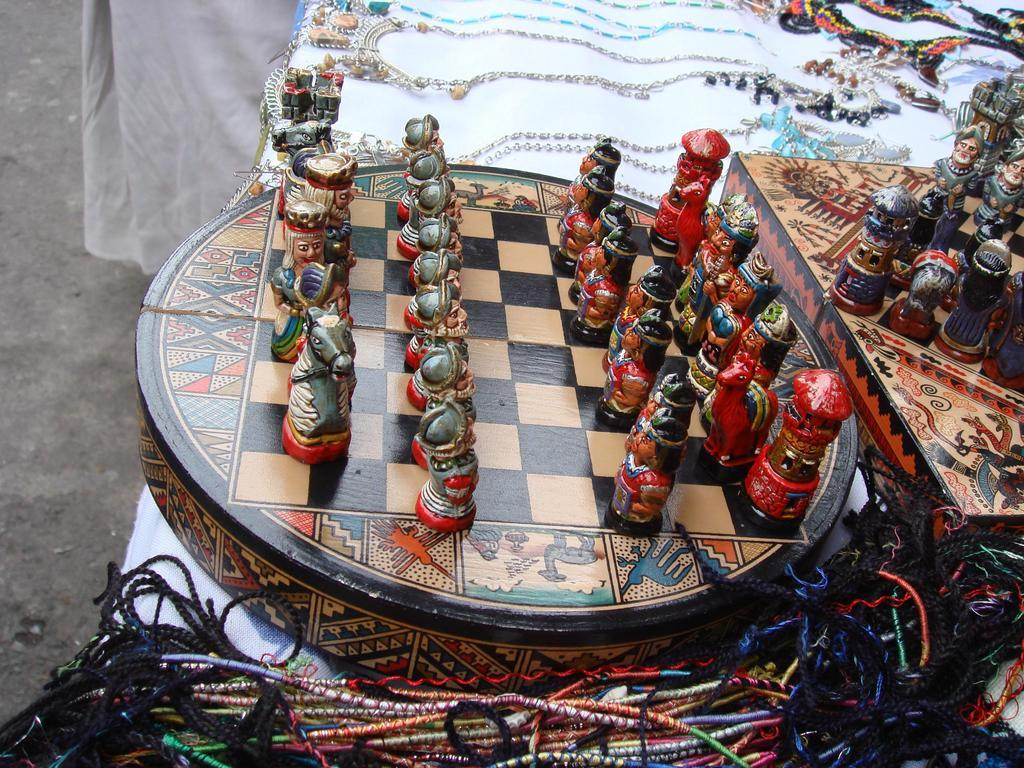What game is being played on the chess board in the image? The image shows a chess board, which is used for playing chess. What pieces are used in the game of chess? There are chess board coins on the board, which are the pieces used in the game of chess. What else can be seen in the image besides the chess board? There are toys on a box and chains visible in the image. How does the grandmother help the players in the game of chess in the image? There is no grandmother present in the image; it only shows a chess board, chess board coins, toys on a box, and chains. What type of pest can be seen crawling on the chess board in the image? There are no pests visible on the chess board in the image; it only shows a chess board, chess board coins, toys on a box, and chains. 